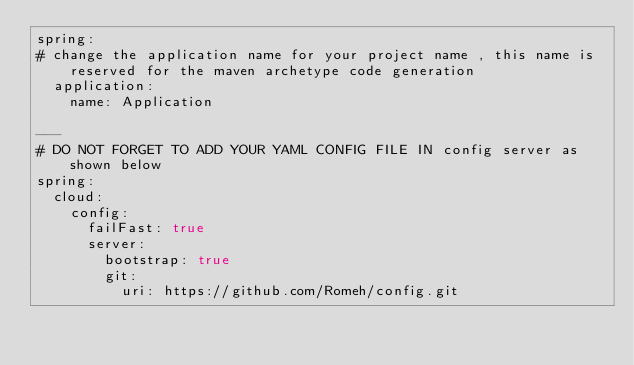Convert code to text. <code><loc_0><loc_0><loc_500><loc_500><_YAML_>spring:
# change the application name for your project name , this name is reserved for the maven archetype code generation
  application:
    name: Application

---
# DO NOT FORGET TO ADD YOUR YAML CONFIG FILE IN config server as shown below
spring:
  cloud:
    config:
      failFast: true
      server:
        bootstrap: true
        git:
          uri: https://github.com/Romeh/config.git
</code> 